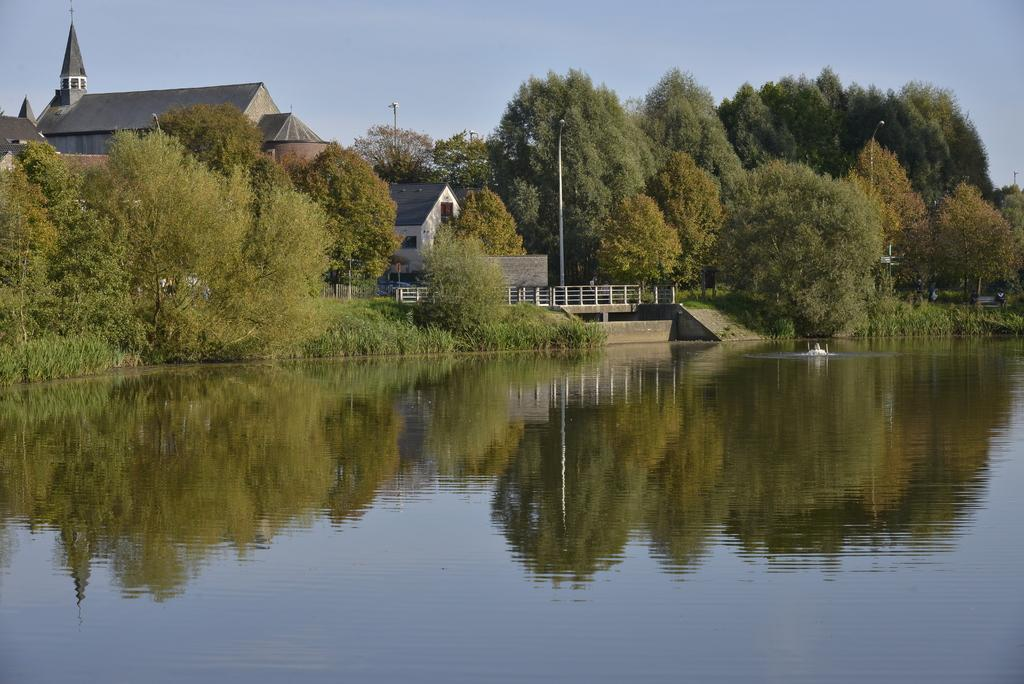What is the primary element visible in the image? There is water in the image. What can be seen in the background of the image? There are trees, light poles, buildings, a railing, and the sky visible in the background of the image. Can you describe the setting of the image? The image appears to be taken near a body of water, with various structures and natural elements in the background. What type of engine can be seen powering the plough in the image? There is no plough or engine present in the image. What is your dad doing in the image? There is no person, including a dad, present in the image. 